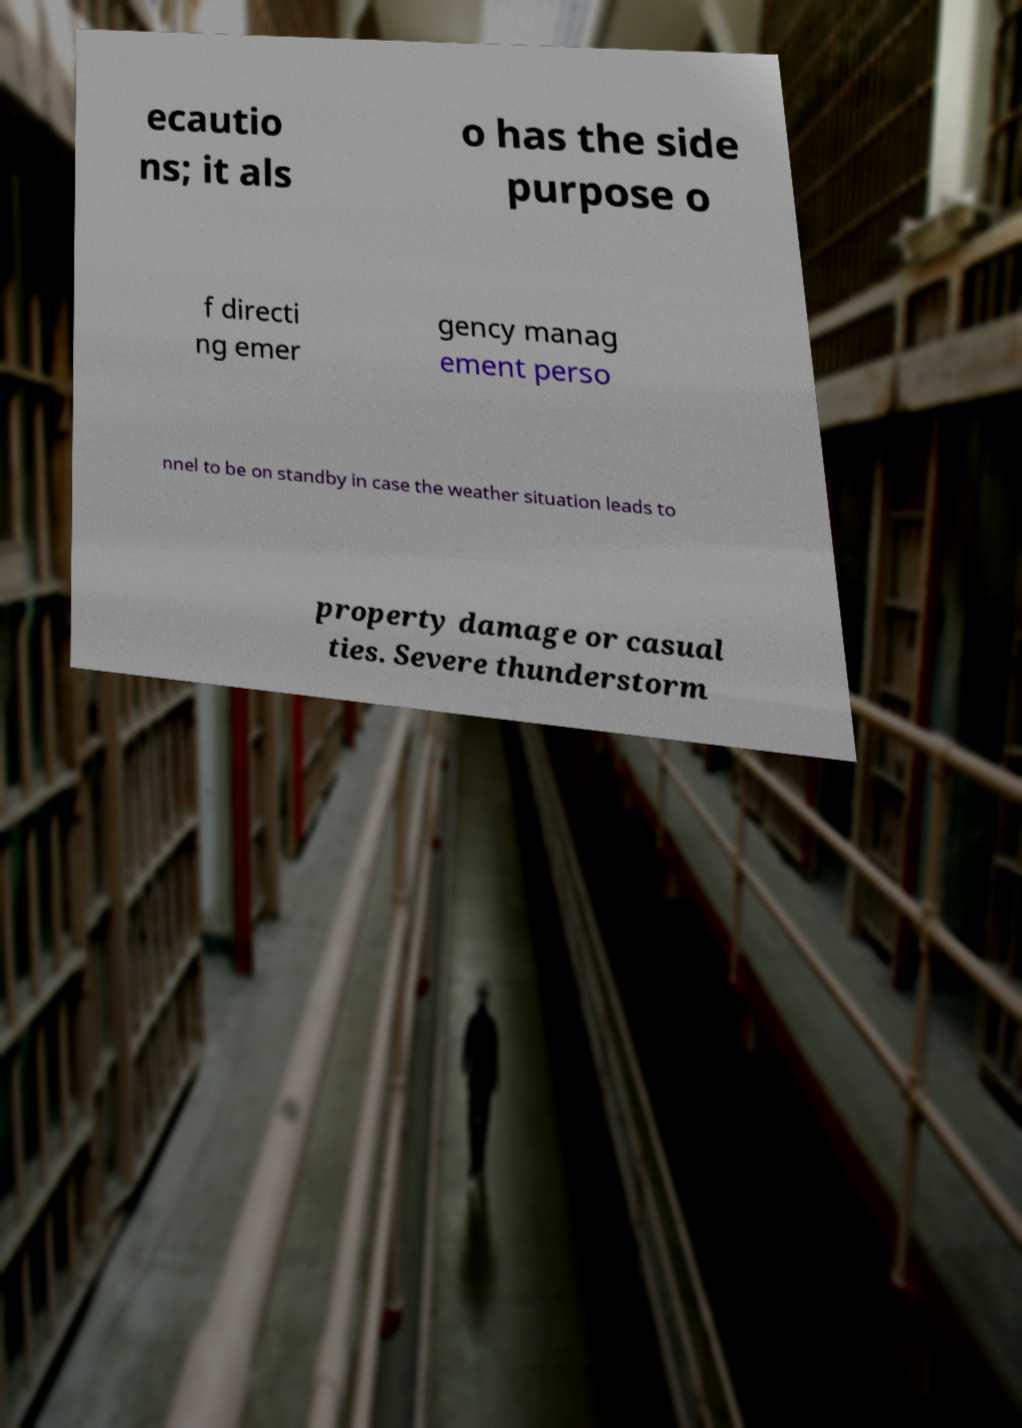There's text embedded in this image that I need extracted. Can you transcribe it verbatim? ecautio ns; it als o has the side purpose o f directi ng emer gency manag ement perso nnel to be on standby in case the weather situation leads to property damage or casual ties. Severe thunderstorm 